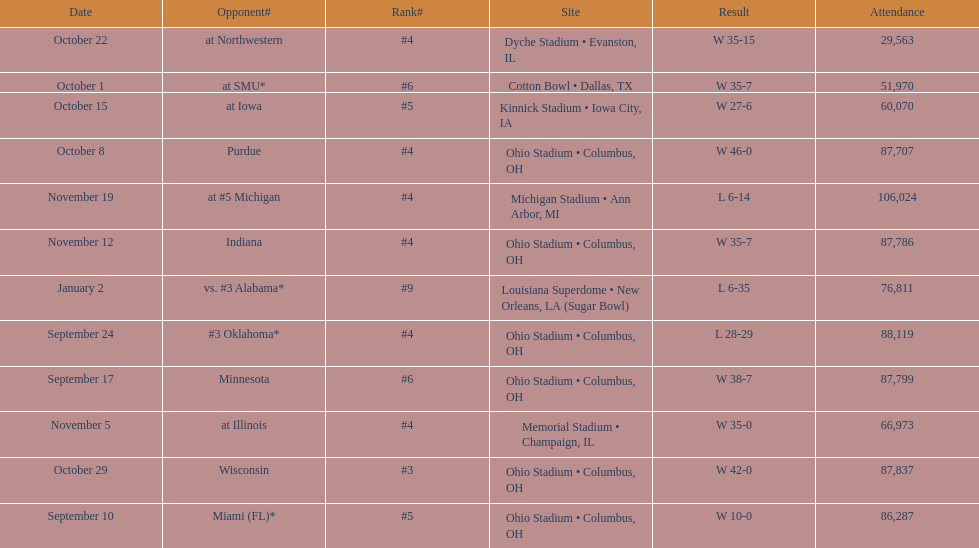What was the last game to be attended by fewer than 30,000 people? October 22. 